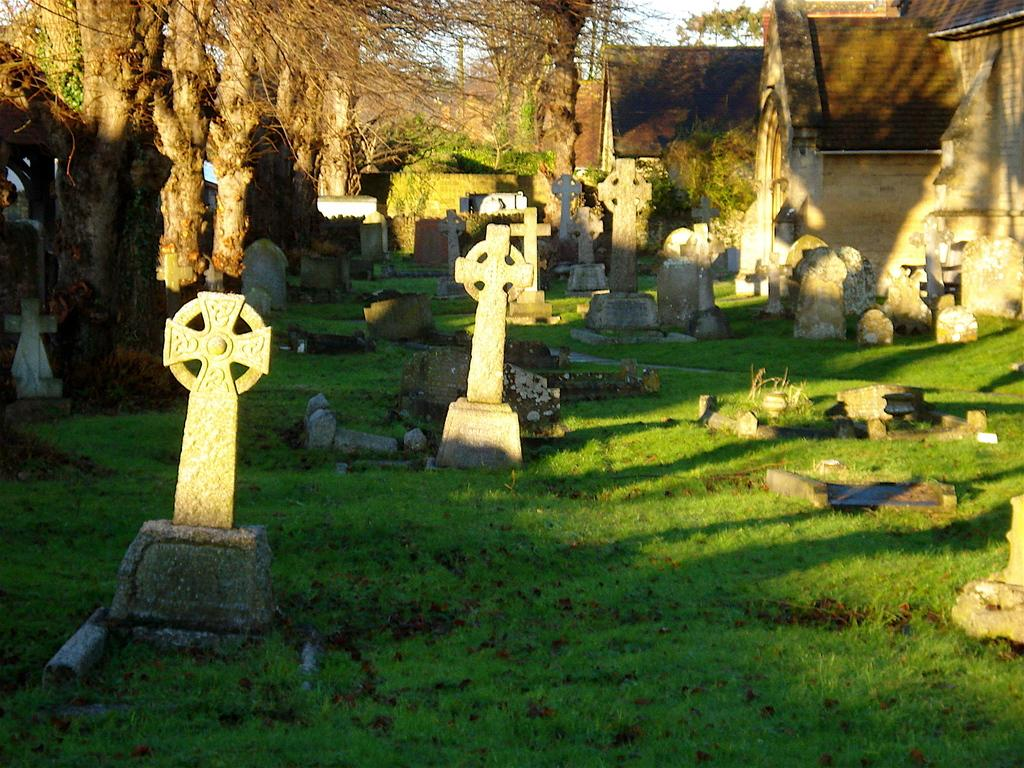What type of structures can be seen in the image? There are grave stones, trees, and houses visible in the image. What type of vegetation is present in the image? There are trees in the image. What is covering the ground in the image? Grass is present on the ground in the image. How many times does the pen appear in the image? There is no pen present in the image. What type of country is depicted in the image? The image does not depict a specific country; it features grave stones, trees, houses, and grass. 